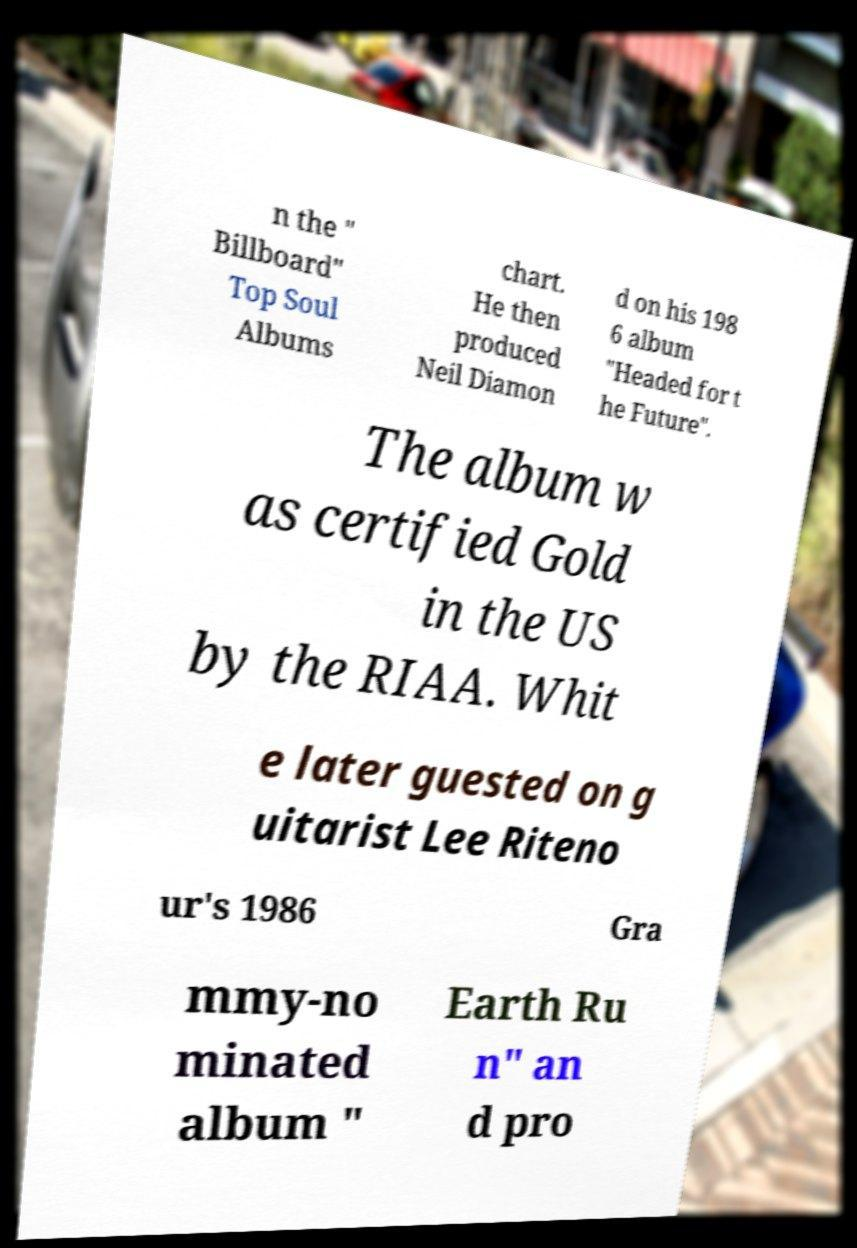Can you accurately transcribe the text from the provided image for me? n the " Billboard" Top Soul Albums chart. He then produced Neil Diamon d on his 198 6 album "Headed for t he Future". The album w as certified Gold in the US by the RIAA. Whit e later guested on g uitarist Lee Riteno ur's 1986 Gra mmy-no minated album " Earth Ru n" an d pro 